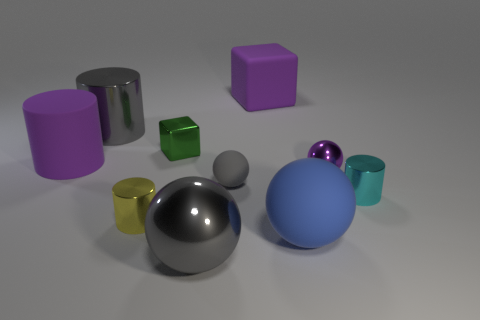Subtract 1 balls. How many balls are left? 3 Subtract all cylinders. How many objects are left? 6 Add 7 big purple things. How many big purple things are left? 9 Add 6 red balls. How many red balls exist? 6 Subtract 1 yellow cylinders. How many objects are left? 9 Subtract all large matte cylinders. Subtract all big matte cubes. How many objects are left? 8 